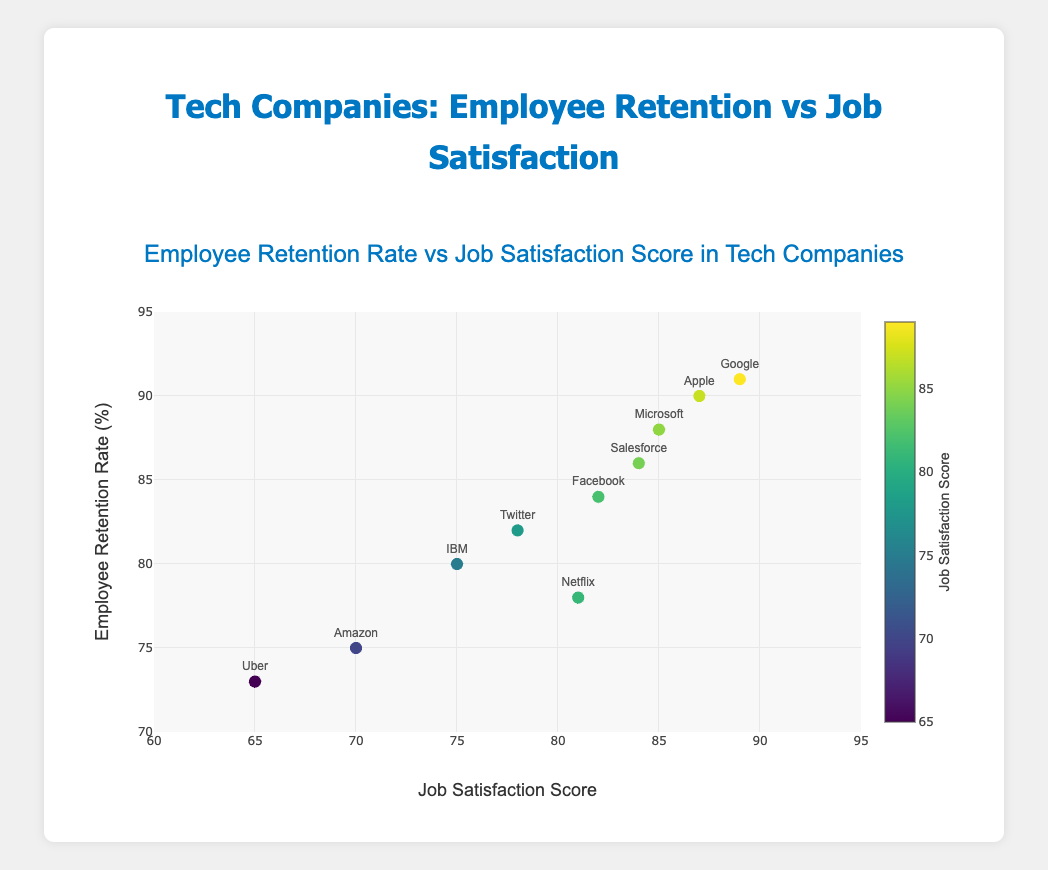Which company has the highest employee retention rate? By looking at the scatter plot, identify the point that is positioned highest on the y-axis, which represents the employee retention rate. The highest point corresponds to Google with a retention rate of 91%.
Answer: Google Which company has the lowest job satisfaction score? Identify the point that is furthest left on the x-axis, which represents the job satisfaction score. The lowest score corresponds to Uber with a score of 65.
Answer: Uber What is the average job satisfaction score across all companies? Add all job satisfaction scores and divide by the number of companies: (89 + 85 + 70 + 82 + 87 + 81 + 84 + 75 + 65 + 78)/10 = 79.6
Answer: 79.6 How does the employee retention rate of Amazon compare to that of Uber? Locate the points for Amazon and Uber on the scatter plot and compare their positions along the y-axis. Amazon has a retention rate of 75%, which is greater than Uber's retention rate of 73%.
Answer: Amazon's is greater Which company has a higher job satisfaction score, Twitter or Microsoft? Locate both Twitter and Microsoft on the scatter plot and compare their positions along the x-axis. Microsoft has a job satisfaction score of 85, which is higher than Twitter’s score of 78.
Answer: Microsoft What is the overall trend between job satisfaction scores and employee retention rates in the scatter plot? Observe the scatter plot to determine if there is a visible trend. Most points tend to increase in the y-axis (retention rate) as they increase in the x-axis (job satisfaction score), indicating a positive correlation.
Answer: Positive correlation If Netflix improved its job satisfaction score to match that of Facebook, what would be its new position on the x-axis? Facebook has a job satisfaction score of 82. Netflix currently has a score of 81. If Netflix improved its score to 82, its new position on the x-axis would be 82.
Answer: 82 What is the difference in employee retention rates between the company with the highest job satisfaction score and the company with the lowest? The highest job satisfaction score is 89 (Google) and the lowest is 65 (Uber). The corresponding retention rates are 91% and 73%. The difference is 91 - 73 = 18%.
Answer: 18% Which company shows a similar pattern in both retention and satisfaction compared to Salesforce? Locate Salesforce on the scatter plot (86% retention, 84 satisfaction). Facebook has nearby points with retention of 84% and satisfaction of 82. This makes Facebook similar to Salesforce in both metrics.
Answer: Facebook How many companies have an employee retention rate above 85%? Count the points on the scatter plot that are above the 85% line on the y-axis. Google, Microsoft, Facebook, Apple, and Salesforce have retention rates above 85%. Therefore, there are 5 companies.
Answer: 5 